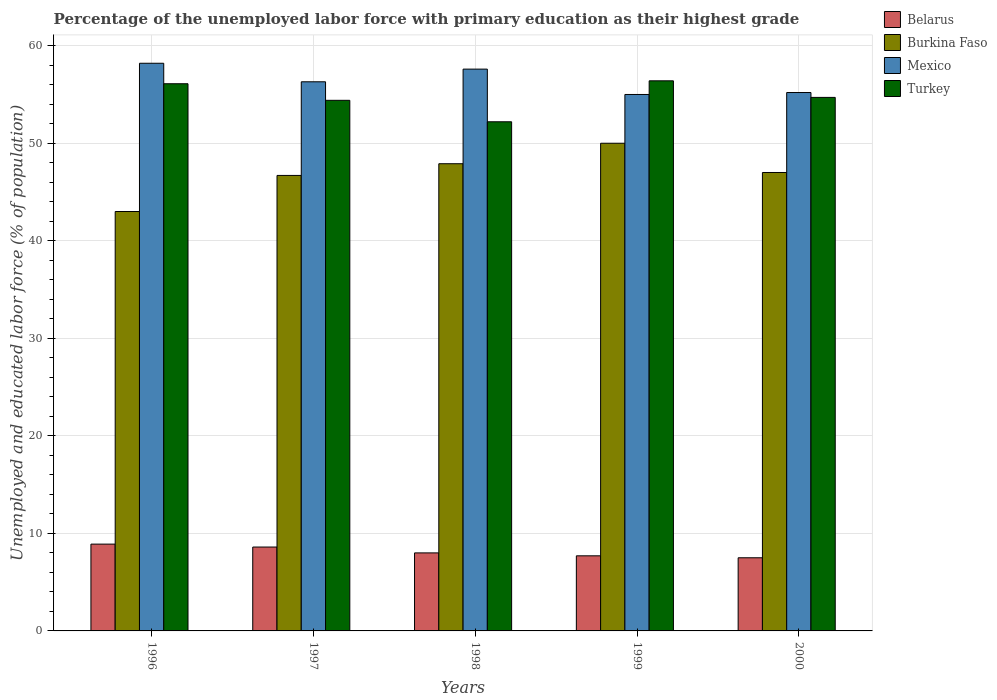How many different coloured bars are there?
Provide a succinct answer. 4. How many groups of bars are there?
Your response must be concise. 5. Are the number of bars on each tick of the X-axis equal?
Offer a very short reply. Yes. What is the label of the 1st group of bars from the left?
Offer a terse response. 1996. What is the percentage of the unemployed labor force with primary education in Mexico in 1996?
Your response must be concise. 58.2. Across all years, what is the maximum percentage of the unemployed labor force with primary education in Turkey?
Keep it short and to the point. 56.4. Across all years, what is the minimum percentage of the unemployed labor force with primary education in Turkey?
Your answer should be compact. 52.2. In which year was the percentage of the unemployed labor force with primary education in Turkey maximum?
Offer a terse response. 1999. In which year was the percentage of the unemployed labor force with primary education in Burkina Faso minimum?
Your answer should be very brief. 1996. What is the total percentage of the unemployed labor force with primary education in Burkina Faso in the graph?
Ensure brevity in your answer.  234.6. What is the difference between the percentage of the unemployed labor force with primary education in Mexico in 1997 and the percentage of the unemployed labor force with primary education in Turkey in 1999?
Offer a terse response. -0.1. What is the average percentage of the unemployed labor force with primary education in Belarus per year?
Make the answer very short. 8.14. In the year 1996, what is the difference between the percentage of the unemployed labor force with primary education in Mexico and percentage of the unemployed labor force with primary education in Burkina Faso?
Your answer should be compact. 15.2. In how many years, is the percentage of the unemployed labor force with primary education in Turkey greater than 14 %?
Offer a very short reply. 5. What is the ratio of the percentage of the unemployed labor force with primary education in Turkey in 1998 to that in 2000?
Keep it short and to the point. 0.95. Is the percentage of the unemployed labor force with primary education in Turkey in 1996 less than that in 2000?
Offer a very short reply. No. What is the difference between the highest and the second highest percentage of the unemployed labor force with primary education in Turkey?
Keep it short and to the point. 0.3. What is the difference between the highest and the lowest percentage of the unemployed labor force with primary education in Mexico?
Your answer should be compact. 3.2. In how many years, is the percentage of the unemployed labor force with primary education in Burkina Faso greater than the average percentage of the unemployed labor force with primary education in Burkina Faso taken over all years?
Keep it short and to the point. 3. Is the sum of the percentage of the unemployed labor force with primary education in Mexico in 1998 and 2000 greater than the maximum percentage of the unemployed labor force with primary education in Burkina Faso across all years?
Your answer should be compact. Yes. Is it the case that in every year, the sum of the percentage of the unemployed labor force with primary education in Turkey and percentage of the unemployed labor force with primary education in Belarus is greater than the sum of percentage of the unemployed labor force with primary education in Burkina Faso and percentage of the unemployed labor force with primary education in Mexico?
Your answer should be very brief. No. What does the 2nd bar from the left in 1997 represents?
Give a very brief answer. Burkina Faso. What does the 1st bar from the right in 1999 represents?
Provide a succinct answer. Turkey. How many bars are there?
Ensure brevity in your answer.  20. How many years are there in the graph?
Provide a succinct answer. 5. What is the difference between two consecutive major ticks on the Y-axis?
Your response must be concise. 10. Are the values on the major ticks of Y-axis written in scientific E-notation?
Make the answer very short. No. Does the graph contain any zero values?
Ensure brevity in your answer.  No. Does the graph contain grids?
Your answer should be very brief. Yes. Where does the legend appear in the graph?
Offer a terse response. Top right. How are the legend labels stacked?
Provide a short and direct response. Vertical. What is the title of the graph?
Offer a terse response. Percentage of the unemployed labor force with primary education as their highest grade. What is the label or title of the X-axis?
Make the answer very short. Years. What is the label or title of the Y-axis?
Provide a succinct answer. Unemployed and educated labor force (% of population). What is the Unemployed and educated labor force (% of population) of Belarus in 1996?
Keep it short and to the point. 8.9. What is the Unemployed and educated labor force (% of population) of Burkina Faso in 1996?
Your answer should be compact. 43. What is the Unemployed and educated labor force (% of population) in Mexico in 1996?
Your response must be concise. 58.2. What is the Unemployed and educated labor force (% of population) in Turkey in 1996?
Ensure brevity in your answer.  56.1. What is the Unemployed and educated labor force (% of population) in Belarus in 1997?
Your answer should be very brief. 8.6. What is the Unemployed and educated labor force (% of population) in Burkina Faso in 1997?
Ensure brevity in your answer.  46.7. What is the Unemployed and educated labor force (% of population) of Mexico in 1997?
Keep it short and to the point. 56.3. What is the Unemployed and educated labor force (% of population) of Turkey in 1997?
Your answer should be compact. 54.4. What is the Unemployed and educated labor force (% of population) in Burkina Faso in 1998?
Keep it short and to the point. 47.9. What is the Unemployed and educated labor force (% of population) in Mexico in 1998?
Ensure brevity in your answer.  57.6. What is the Unemployed and educated labor force (% of population) of Turkey in 1998?
Your answer should be very brief. 52.2. What is the Unemployed and educated labor force (% of population) of Belarus in 1999?
Provide a succinct answer. 7.7. What is the Unemployed and educated labor force (% of population) of Burkina Faso in 1999?
Your response must be concise. 50. What is the Unemployed and educated labor force (% of population) of Mexico in 1999?
Provide a short and direct response. 55. What is the Unemployed and educated labor force (% of population) of Turkey in 1999?
Make the answer very short. 56.4. What is the Unemployed and educated labor force (% of population) in Mexico in 2000?
Provide a succinct answer. 55.2. What is the Unemployed and educated labor force (% of population) of Turkey in 2000?
Your answer should be compact. 54.7. Across all years, what is the maximum Unemployed and educated labor force (% of population) in Belarus?
Make the answer very short. 8.9. Across all years, what is the maximum Unemployed and educated labor force (% of population) of Burkina Faso?
Provide a succinct answer. 50. Across all years, what is the maximum Unemployed and educated labor force (% of population) in Mexico?
Offer a very short reply. 58.2. Across all years, what is the maximum Unemployed and educated labor force (% of population) in Turkey?
Provide a short and direct response. 56.4. Across all years, what is the minimum Unemployed and educated labor force (% of population) in Burkina Faso?
Give a very brief answer. 43. Across all years, what is the minimum Unemployed and educated labor force (% of population) in Turkey?
Your response must be concise. 52.2. What is the total Unemployed and educated labor force (% of population) of Belarus in the graph?
Provide a succinct answer. 40.7. What is the total Unemployed and educated labor force (% of population) in Burkina Faso in the graph?
Your answer should be compact. 234.6. What is the total Unemployed and educated labor force (% of population) in Mexico in the graph?
Offer a terse response. 282.3. What is the total Unemployed and educated labor force (% of population) of Turkey in the graph?
Your answer should be compact. 273.8. What is the difference between the Unemployed and educated labor force (% of population) of Mexico in 1996 and that in 1997?
Ensure brevity in your answer.  1.9. What is the difference between the Unemployed and educated labor force (% of population) of Belarus in 1996 and that in 1998?
Your answer should be compact. 0.9. What is the difference between the Unemployed and educated labor force (% of population) in Mexico in 1996 and that in 1999?
Your response must be concise. 3.2. What is the difference between the Unemployed and educated labor force (% of population) of Turkey in 1996 and that in 1999?
Your response must be concise. -0.3. What is the difference between the Unemployed and educated labor force (% of population) in Burkina Faso in 1996 and that in 2000?
Provide a short and direct response. -4. What is the difference between the Unemployed and educated labor force (% of population) in Mexico in 1996 and that in 2000?
Keep it short and to the point. 3. What is the difference between the Unemployed and educated labor force (% of population) of Turkey in 1996 and that in 2000?
Your response must be concise. 1.4. What is the difference between the Unemployed and educated labor force (% of population) of Burkina Faso in 1997 and that in 1998?
Give a very brief answer. -1.2. What is the difference between the Unemployed and educated labor force (% of population) of Mexico in 1997 and that in 1998?
Provide a succinct answer. -1.3. What is the difference between the Unemployed and educated labor force (% of population) in Burkina Faso in 1997 and that in 1999?
Ensure brevity in your answer.  -3.3. What is the difference between the Unemployed and educated labor force (% of population) of Mexico in 1997 and that in 1999?
Your answer should be very brief. 1.3. What is the difference between the Unemployed and educated labor force (% of population) of Turkey in 1997 and that in 1999?
Give a very brief answer. -2. What is the difference between the Unemployed and educated labor force (% of population) in Burkina Faso in 1997 and that in 2000?
Your response must be concise. -0.3. What is the difference between the Unemployed and educated labor force (% of population) in Mexico in 1997 and that in 2000?
Ensure brevity in your answer.  1.1. What is the difference between the Unemployed and educated labor force (% of population) in Turkey in 1997 and that in 2000?
Your answer should be compact. -0.3. What is the difference between the Unemployed and educated labor force (% of population) in Belarus in 1998 and that in 1999?
Provide a short and direct response. 0.3. What is the difference between the Unemployed and educated labor force (% of population) of Mexico in 1998 and that in 1999?
Make the answer very short. 2.6. What is the difference between the Unemployed and educated labor force (% of population) in Belarus in 1998 and that in 2000?
Keep it short and to the point. 0.5. What is the difference between the Unemployed and educated labor force (% of population) of Burkina Faso in 1998 and that in 2000?
Ensure brevity in your answer.  0.9. What is the difference between the Unemployed and educated labor force (% of population) of Mexico in 1998 and that in 2000?
Provide a succinct answer. 2.4. What is the difference between the Unemployed and educated labor force (% of population) in Burkina Faso in 1999 and that in 2000?
Your answer should be compact. 3. What is the difference between the Unemployed and educated labor force (% of population) of Mexico in 1999 and that in 2000?
Provide a short and direct response. -0.2. What is the difference between the Unemployed and educated labor force (% of population) in Belarus in 1996 and the Unemployed and educated labor force (% of population) in Burkina Faso in 1997?
Your answer should be compact. -37.8. What is the difference between the Unemployed and educated labor force (% of population) in Belarus in 1996 and the Unemployed and educated labor force (% of population) in Mexico in 1997?
Give a very brief answer. -47.4. What is the difference between the Unemployed and educated labor force (% of population) of Belarus in 1996 and the Unemployed and educated labor force (% of population) of Turkey in 1997?
Provide a succinct answer. -45.5. What is the difference between the Unemployed and educated labor force (% of population) of Burkina Faso in 1996 and the Unemployed and educated labor force (% of population) of Mexico in 1997?
Provide a succinct answer. -13.3. What is the difference between the Unemployed and educated labor force (% of population) of Belarus in 1996 and the Unemployed and educated labor force (% of population) of Burkina Faso in 1998?
Your response must be concise. -39. What is the difference between the Unemployed and educated labor force (% of population) of Belarus in 1996 and the Unemployed and educated labor force (% of population) of Mexico in 1998?
Provide a succinct answer. -48.7. What is the difference between the Unemployed and educated labor force (% of population) in Belarus in 1996 and the Unemployed and educated labor force (% of population) in Turkey in 1998?
Your answer should be compact. -43.3. What is the difference between the Unemployed and educated labor force (% of population) of Burkina Faso in 1996 and the Unemployed and educated labor force (% of population) of Mexico in 1998?
Provide a short and direct response. -14.6. What is the difference between the Unemployed and educated labor force (% of population) of Mexico in 1996 and the Unemployed and educated labor force (% of population) of Turkey in 1998?
Your answer should be compact. 6. What is the difference between the Unemployed and educated labor force (% of population) of Belarus in 1996 and the Unemployed and educated labor force (% of population) of Burkina Faso in 1999?
Offer a terse response. -41.1. What is the difference between the Unemployed and educated labor force (% of population) in Belarus in 1996 and the Unemployed and educated labor force (% of population) in Mexico in 1999?
Provide a short and direct response. -46.1. What is the difference between the Unemployed and educated labor force (% of population) in Belarus in 1996 and the Unemployed and educated labor force (% of population) in Turkey in 1999?
Give a very brief answer. -47.5. What is the difference between the Unemployed and educated labor force (% of population) of Burkina Faso in 1996 and the Unemployed and educated labor force (% of population) of Mexico in 1999?
Give a very brief answer. -12. What is the difference between the Unemployed and educated labor force (% of population) in Belarus in 1996 and the Unemployed and educated labor force (% of population) in Burkina Faso in 2000?
Provide a short and direct response. -38.1. What is the difference between the Unemployed and educated labor force (% of population) of Belarus in 1996 and the Unemployed and educated labor force (% of population) of Mexico in 2000?
Keep it short and to the point. -46.3. What is the difference between the Unemployed and educated labor force (% of population) in Belarus in 1996 and the Unemployed and educated labor force (% of population) in Turkey in 2000?
Ensure brevity in your answer.  -45.8. What is the difference between the Unemployed and educated labor force (% of population) of Burkina Faso in 1996 and the Unemployed and educated labor force (% of population) of Turkey in 2000?
Keep it short and to the point. -11.7. What is the difference between the Unemployed and educated labor force (% of population) of Belarus in 1997 and the Unemployed and educated labor force (% of population) of Burkina Faso in 1998?
Your answer should be compact. -39.3. What is the difference between the Unemployed and educated labor force (% of population) of Belarus in 1997 and the Unemployed and educated labor force (% of population) of Mexico in 1998?
Ensure brevity in your answer.  -49. What is the difference between the Unemployed and educated labor force (% of population) of Belarus in 1997 and the Unemployed and educated labor force (% of population) of Turkey in 1998?
Provide a short and direct response. -43.6. What is the difference between the Unemployed and educated labor force (% of population) of Burkina Faso in 1997 and the Unemployed and educated labor force (% of population) of Mexico in 1998?
Make the answer very short. -10.9. What is the difference between the Unemployed and educated labor force (% of population) in Burkina Faso in 1997 and the Unemployed and educated labor force (% of population) in Turkey in 1998?
Your answer should be compact. -5.5. What is the difference between the Unemployed and educated labor force (% of population) of Belarus in 1997 and the Unemployed and educated labor force (% of population) of Burkina Faso in 1999?
Keep it short and to the point. -41.4. What is the difference between the Unemployed and educated labor force (% of population) in Belarus in 1997 and the Unemployed and educated labor force (% of population) in Mexico in 1999?
Make the answer very short. -46.4. What is the difference between the Unemployed and educated labor force (% of population) in Belarus in 1997 and the Unemployed and educated labor force (% of population) in Turkey in 1999?
Ensure brevity in your answer.  -47.8. What is the difference between the Unemployed and educated labor force (% of population) of Burkina Faso in 1997 and the Unemployed and educated labor force (% of population) of Mexico in 1999?
Your response must be concise. -8.3. What is the difference between the Unemployed and educated labor force (% of population) of Burkina Faso in 1997 and the Unemployed and educated labor force (% of population) of Turkey in 1999?
Give a very brief answer. -9.7. What is the difference between the Unemployed and educated labor force (% of population) of Belarus in 1997 and the Unemployed and educated labor force (% of population) of Burkina Faso in 2000?
Keep it short and to the point. -38.4. What is the difference between the Unemployed and educated labor force (% of population) of Belarus in 1997 and the Unemployed and educated labor force (% of population) of Mexico in 2000?
Make the answer very short. -46.6. What is the difference between the Unemployed and educated labor force (% of population) in Belarus in 1997 and the Unemployed and educated labor force (% of population) in Turkey in 2000?
Give a very brief answer. -46.1. What is the difference between the Unemployed and educated labor force (% of population) of Burkina Faso in 1997 and the Unemployed and educated labor force (% of population) of Mexico in 2000?
Ensure brevity in your answer.  -8.5. What is the difference between the Unemployed and educated labor force (% of population) in Burkina Faso in 1997 and the Unemployed and educated labor force (% of population) in Turkey in 2000?
Offer a very short reply. -8. What is the difference between the Unemployed and educated labor force (% of population) of Mexico in 1997 and the Unemployed and educated labor force (% of population) of Turkey in 2000?
Your response must be concise. 1.6. What is the difference between the Unemployed and educated labor force (% of population) of Belarus in 1998 and the Unemployed and educated labor force (% of population) of Burkina Faso in 1999?
Provide a succinct answer. -42. What is the difference between the Unemployed and educated labor force (% of population) in Belarus in 1998 and the Unemployed and educated labor force (% of population) in Mexico in 1999?
Provide a succinct answer. -47. What is the difference between the Unemployed and educated labor force (% of population) of Belarus in 1998 and the Unemployed and educated labor force (% of population) of Turkey in 1999?
Make the answer very short. -48.4. What is the difference between the Unemployed and educated labor force (% of population) in Burkina Faso in 1998 and the Unemployed and educated labor force (% of population) in Turkey in 1999?
Your response must be concise. -8.5. What is the difference between the Unemployed and educated labor force (% of population) in Mexico in 1998 and the Unemployed and educated labor force (% of population) in Turkey in 1999?
Offer a very short reply. 1.2. What is the difference between the Unemployed and educated labor force (% of population) in Belarus in 1998 and the Unemployed and educated labor force (% of population) in Burkina Faso in 2000?
Offer a very short reply. -39. What is the difference between the Unemployed and educated labor force (% of population) of Belarus in 1998 and the Unemployed and educated labor force (% of population) of Mexico in 2000?
Your response must be concise. -47.2. What is the difference between the Unemployed and educated labor force (% of population) in Belarus in 1998 and the Unemployed and educated labor force (% of population) in Turkey in 2000?
Keep it short and to the point. -46.7. What is the difference between the Unemployed and educated labor force (% of population) in Burkina Faso in 1998 and the Unemployed and educated labor force (% of population) in Mexico in 2000?
Offer a very short reply. -7.3. What is the difference between the Unemployed and educated labor force (% of population) in Burkina Faso in 1998 and the Unemployed and educated labor force (% of population) in Turkey in 2000?
Give a very brief answer. -6.8. What is the difference between the Unemployed and educated labor force (% of population) in Belarus in 1999 and the Unemployed and educated labor force (% of population) in Burkina Faso in 2000?
Your response must be concise. -39.3. What is the difference between the Unemployed and educated labor force (% of population) of Belarus in 1999 and the Unemployed and educated labor force (% of population) of Mexico in 2000?
Provide a short and direct response. -47.5. What is the difference between the Unemployed and educated labor force (% of population) in Belarus in 1999 and the Unemployed and educated labor force (% of population) in Turkey in 2000?
Offer a very short reply. -47. What is the difference between the Unemployed and educated labor force (% of population) of Mexico in 1999 and the Unemployed and educated labor force (% of population) of Turkey in 2000?
Provide a short and direct response. 0.3. What is the average Unemployed and educated labor force (% of population) of Belarus per year?
Your answer should be very brief. 8.14. What is the average Unemployed and educated labor force (% of population) of Burkina Faso per year?
Make the answer very short. 46.92. What is the average Unemployed and educated labor force (% of population) in Mexico per year?
Offer a terse response. 56.46. What is the average Unemployed and educated labor force (% of population) in Turkey per year?
Your response must be concise. 54.76. In the year 1996, what is the difference between the Unemployed and educated labor force (% of population) of Belarus and Unemployed and educated labor force (% of population) of Burkina Faso?
Your answer should be very brief. -34.1. In the year 1996, what is the difference between the Unemployed and educated labor force (% of population) of Belarus and Unemployed and educated labor force (% of population) of Mexico?
Provide a succinct answer. -49.3. In the year 1996, what is the difference between the Unemployed and educated labor force (% of population) of Belarus and Unemployed and educated labor force (% of population) of Turkey?
Offer a terse response. -47.2. In the year 1996, what is the difference between the Unemployed and educated labor force (% of population) of Burkina Faso and Unemployed and educated labor force (% of population) of Mexico?
Make the answer very short. -15.2. In the year 1996, what is the difference between the Unemployed and educated labor force (% of population) in Mexico and Unemployed and educated labor force (% of population) in Turkey?
Give a very brief answer. 2.1. In the year 1997, what is the difference between the Unemployed and educated labor force (% of population) in Belarus and Unemployed and educated labor force (% of population) in Burkina Faso?
Provide a succinct answer. -38.1. In the year 1997, what is the difference between the Unemployed and educated labor force (% of population) of Belarus and Unemployed and educated labor force (% of population) of Mexico?
Your answer should be very brief. -47.7. In the year 1997, what is the difference between the Unemployed and educated labor force (% of population) of Belarus and Unemployed and educated labor force (% of population) of Turkey?
Your response must be concise. -45.8. In the year 1997, what is the difference between the Unemployed and educated labor force (% of population) in Burkina Faso and Unemployed and educated labor force (% of population) in Turkey?
Offer a terse response. -7.7. In the year 1997, what is the difference between the Unemployed and educated labor force (% of population) in Mexico and Unemployed and educated labor force (% of population) in Turkey?
Ensure brevity in your answer.  1.9. In the year 1998, what is the difference between the Unemployed and educated labor force (% of population) in Belarus and Unemployed and educated labor force (% of population) in Burkina Faso?
Give a very brief answer. -39.9. In the year 1998, what is the difference between the Unemployed and educated labor force (% of population) in Belarus and Unemployed and educated labor force (% of population) in Mexico?
Offer a very short reply. -49.6. In the year 1998, what is the difference between the Unemployed and educated labor force (% of population) in Belarus and Unemployed and educated labor force (% of population) in Turkey?
Keep it short and to the point. -44.2. In the year 1998, what is the difference between the Unemployed and educated labor force (% of population) of Mexico and Unemployed and educated labor force (% of population) of Turkey?
Offer a terse response. 5.4. In the year 1999, what is the difference between the Unemployed and educated labor force (% of population) of Belarus and Unemployed and educated labor force (% of population) of Burkina Faso?
Your response must be concise. -42.3. In the year 1999, what is the difference between the Unemployed and educated labor force (% of population) in Belarus and Unemployed and educated labor force (% of population) in Mexico?
Offer a terse response. -47.3. In the year 1999, what is the difference between the Unemployed and educated labor force (% of population) in Belarus and Unemployed and educated labor force (% of population) in Turkey?
Keep it short and to the point. -48.7. In the year 1999, what is the difference between the Unemployed and educated labor force (% of population) of Burkina Faso and Unemployed and educated labor force (% of population) of Mexico?
Your answer should be compact. -5. In the year 1999, what is the difference between the Unemployed and educated labor force (% of population) in Burkina Faso and Unemployed and educated labor force (% of population) in Turkey?
Provide a short and direct response. -6.4. In the year 1999, what is the difference between the Unemployed and educated labor force (% of population) of Mexico and Unemployed and educated labor force (% of population) of Turkey?
Make the answer very short. -1.4. In the year 2000, what is the difference between the Unemployed and educated labor force (% of population) in Belarus and Unemployed and educated labor force (% of population) in Burkina Faso?
Your response must be concise. -39.5. In the year 2000, what is the difference between the Unemployed and educated labor force (% of population) in Belarus and Unemployed and educated labor force (% of population) in Mexico?
Make the answer very short. -47.7. In the year 2000, what is the difference between the Unemployed and educated labor force (% of population) in Belarus and Unemployed and educated labor force (% of population) in Turkey?
Your answer should be very brief. -47.2. In the year 2000, what is the difference between the Unemployed and educated labor force (% of population) of Burkina Faso and Unemployed and educated labor force (% of population) of Mexico?
Offer a very short reply. -8.2. In the year 2000, what is the difference between the Unemployed and educated labor force (% of population) of Burkina Faso and Unemployed and educated labor force (% of population) of Turkey?
Make the answer very short. -7.7. What is the ratio of the Unemployed and educated labor force (% of population) of Belarus in 1996 to that in 1997?
Provide a short and direct response. 1.03. What is the ratio of the Unemployed and educated labor force (% of population) of Burkina Faso in 1996 to that in 1997?
Provide a succinct answer. 0.92. What is the ratio of the Unemployed and educated labor force (% of population) of Mexico in 1996 to that in 1997?
Your response must be concise. 1.03. What is the ratio of the Unemployed and educated labor force (% of population) in Turkey in 1996 to that in 1997?
Offer a very short reply. 1.03. What is the ratio of the Unemployed and educated labor force (% of population) of Belarus in 1996 to that in 1998?
Your response must be concise. 1.11. What is the ratio of the Unemployed and educated labor force (% of population) in Burkina Faso in 1996 to that in 1998?
Give a very brief answer. 0.9. What is the ratio of the Unemployed and educated labor force (% of population) of Mexico in 1996 to that in 1998?
Make the answer very short. 1.01. What is the ratio of the Unemployed and educated labor force (% of population) in Turkey in 1996 to that in 1998?
Offer a terse response. 1.07. What is the ratio of the Unemployed and educated labor force (% of population) of Belarus in 1996 to that in 1999?
Give a very brief answer. 1.16. What is the ratio of the Unemployed and educated labor force (% of population) in Burkina Faso in 1996 to that in 1999?
Offer a terse response. 0.86. What is the ratio of the Unemployed and educated labor force (% of population) in Mexico in 1996 to that in 1999?
Your answer should be very brief. 1.06. What is the ratio of the Unemployed and educated labor force (% of population) in Belarus in 1996 to that in 2000?
Keep it short and to the point. 1.19. What is the ratio of the Unemployed and educated labor force (% of population) of Burkina Faso in 1996 to that in 2000?
Provide a short and direct response. 0.91. What is the ratio of the Unemployed and educated labor force (% of population) in Mexico in 1996 to that in 2000?
Your answer should be compact. 1.05. What is the ratio of the Unemployed and educated labor force (% of population) in Turkey in 1996 to that in 2000?
Your answer should be very brief. 1.03. What is the ratio of the Unemployed and educated labor force (% of population) in Belarus in 1997 to that in 1998?
Keep it short and to the point. 1.07. What is the ratio of the Unemployed and educated labor force (% of population) of Burkina Faso in 1997 to that in 1998?
Give a very brief answer. 0.97. What is the ratio of the Unemployed and educated labor force (% of population) of Mexico in 1997 to that in 1998?
Make the answer very short. 0.98. What is the ratio of the Unemployed and educated labor force (% of population) of Turkey in 1997 to that in 1998?
Provide a succinct answer. 1.04. What is the ratio of the Unemployed and educated labor force (% of population) of Belarus in 1997 to that in 1999?
Give a very brief answer. 1.12. What is the ratio of the Unemployed and educated labor force (% of population) in Burkina Faso in 1997 to that in 1999?
Your response must be concise. 0.93. What is the ratio of the Unemployed and educated labor force (% of population) in Mexico in 1997 to that in 1999?
Your answer should be compact. 1.02. What is the ratio of the Unemployed and educated labor force (% of population) of Turkey in 1997 to that in 1999?
Ensure brevity in your answer.  0.96. What is the ratio of the Unemployed and educated labor force (% of population) in Belarus in 1997 to that in 2000?
Provide a short and direct response. 1.15. What is the ratio of the Unemployed and educated labor force (% of population) in Burkina Faso in 1997 to that in 2000?
Keep it short and to the point. 0.99. What is the ratio of the Unemployed and educated labor force (% of population) of Mexico in 1997 to that in 2000?
Provide a succinct answer. 1.02. What is the ratio of the Unemployed and educated labor force (% of population) of Turkey in 1997 to that in 2000?
Give a very brief answer. 0.99. What is the ratio of the Unemployed and educated labor force (% of population) in Belarus in 1998 to that in 1999?
Provide a short and direct response. 1.04. What is the ratio of the Unemployed and educated labor force (% of population) of Burkina Faso in 1998 to that in 1999?
Your response must be concise. 0.96. What is the ratio of the Unemployed and educated labor force (% of population) in Mexico in 1998 to that in 1999?
Keep it short and to the point. 1.05. What is the ratio of the Unemployed and educated labor force (% of population) of Turkey in 1998 to that in 1999?
Keep it short and to the point. 0.93. What is the ratio of the Unemployed and educated labor force (% of population) in Belarus in 1998 to that in 2000?
Your response must be concise. 1.07. What is the ratio of the Unemployed and educated labor force (% of population) in Burkina Faso in 1998 to that in 2000?
Offer a terse response. 1.02. What is the ratio of the Unemployed and educated labor force (% of population) in Mexico in 1998 to that in 2000?
Your answer should be compact. 1.04. What is the ratio of the Unemployed and educated labor force (% of population) in Turkey in 1998 to that in 2000?
Give a very brief answer. 0.95. What is the ratio of the Unemployed and educated labor force (% of population) in Belarus in 1999 to that in 2000?
Ensure brevity in your answer.  1.03. What is the ratio of the Unemployed and educated labor force (% of population) of Burkina Faso in 1999 to that in 2000?
Provide a short and direct response. 1.06. What is the ratio of the Unemployed and educated labor force (% of population) of Turkey in 1999 to that in 2000?
Provide a succinct answer. 1.03. What is the difference between the highest and the second highest Unemployed and educated labor force (% of population) of Belarus?
Ensure brevity in your answer.  0.3. What is the difference between the highest and the second highest Unemployed and educated labor force (% of population) in Burkina Faso?
Your answer should be very brief. 2.1. What is the difference between the highest and the second highest Unemployed and educated labor force (% of population) of Mexico?
Make the answer very short. 0.6. What is the difference between the highest and the second highest Unemployed and educated labor force (% of population) of Turkey?
Make the answer very short. 0.3. What is the difference between the highest and the lowest Unemployed and educated labor force (% of population) of Belarus?
Your answer should be very brief. 1.4. What is the difference between the highest and the lowest Unemployed and educated labor force (% of population) of Mexico?
Offer a terse response. 3.2. What is the difference between the highest and the lowest Unemployed and educated labor force (% of population) in Turkey?
Keep it short and to the point. 4.2. 